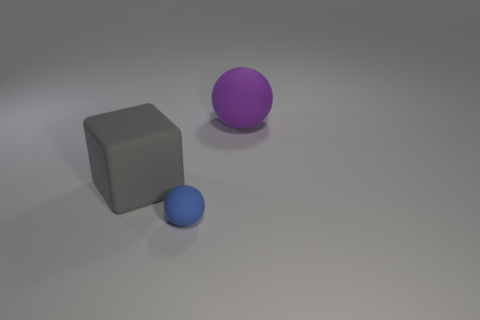Does the large sphere have the same material as the blue ball?
Offer a terse response. Yes. What number of things are rubber objects in front of the big purple matte object or blue rubber objects left of the big purple thing?
Ensure brevity in your answer.  2. Are there any objects that have the same size as the blue sphere?
Your answer should be very brief. No. There is another tiny rubber object that is the same shape as the purple thing; what color is it?
Keep it short and to the point. Blue. There is a large object that is right of the tiny object; are there any big matte objects that are left of it?
Ensure brevity in your answer.  Yes. There is a rubber object behind the gray thing; is its shape the same as the gray matte thing?
Offer a very short reply. No. What is the shape of the purple object?
Give a very brief answer. Sphere. How many large purple objects are made of the same material as the gray object?
Provide a short and direct response. 1. Do the small rubber thing and the matte cube that is to the left of the big purple sphere have the same color?
Your answer should be very brief. No. How many purple matte spheres are there?
Offer a terse response. 1. 